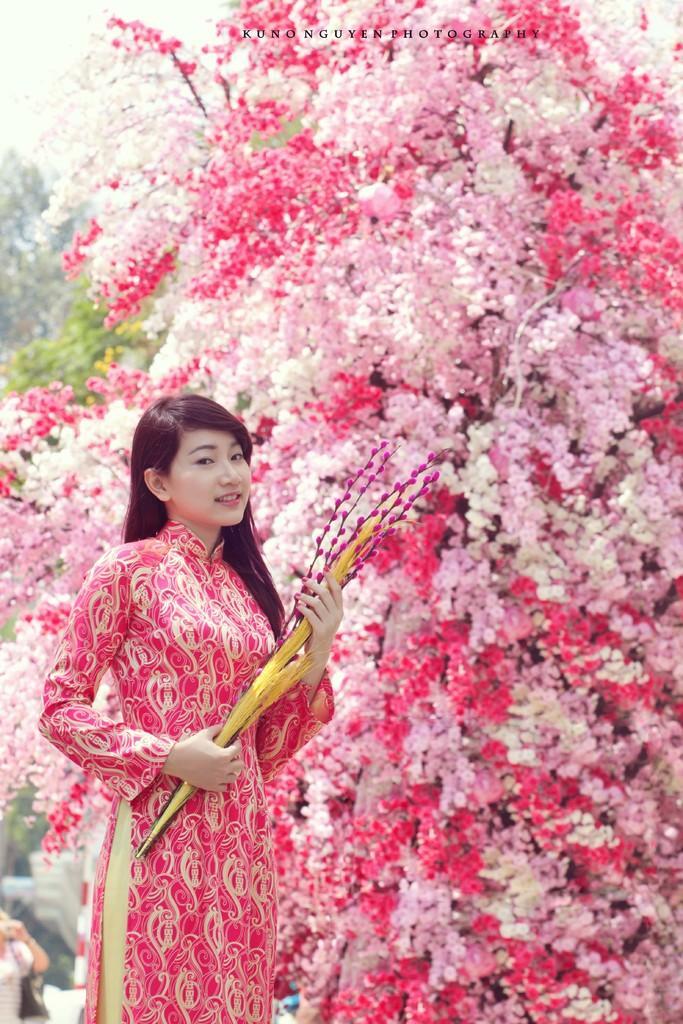Describe this image in one or two sentences. As we can see in the image there are trees, flowers, sky and a woman standing in the front. 